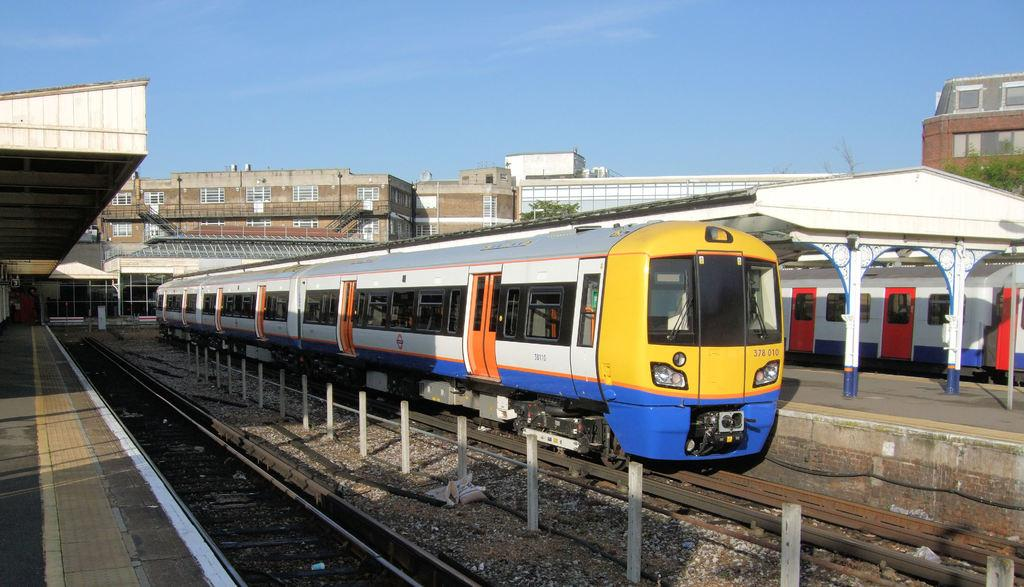What is the main subject in the center of the image? There is a train in the center of the image. What is the train's position in relation to the track? The train is on a track. What can be seen in the background of the image? There are buildings, trees, and the sky visible in the background of the image. To create the conversation, we first identify the main subject, which is the train. We then describe its position and the surrounding elements in the image, such as the track, buildings, trees, and sky. Each question is designed to elicit a specific detail about the image that is known from the provided facts. What type of juice is being served on the boat in the image? There is no boat present in the image, and therefore no juice can be served on it. 